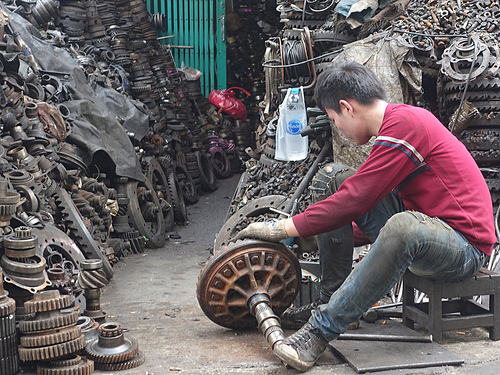<image>
Is the bag on the ground? No. The bag is not positioned on the ground. They may be near each other, but the bag is not supported by or resting on top of the ground. Is the gear in front of the man? Yes. The gear is positioned in front of the man, appearing closer to the camera viewpoint. 